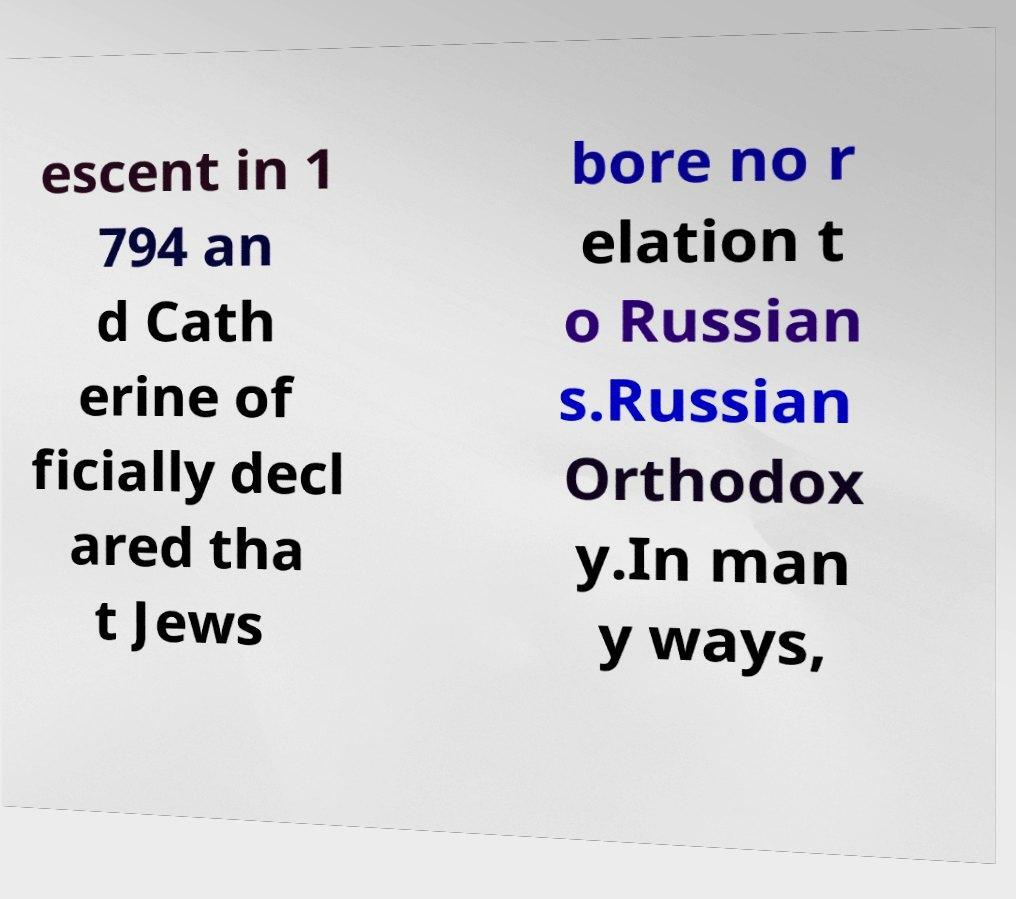There's text embedded in this image that I need extracted. Can you transcribe it verbatim? escent in 1 794 an d Cath erine of ficially decl ared tha t Jews bore no r elation t o Russian s.Russian Orthodox y.In man y ways, 